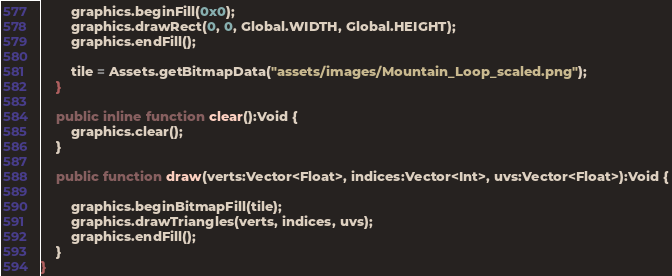<code> <loc_0><loc_0><loc_500><loc_500><_Haxe_>		graphics.beginFill(0x0);
		graphics.drawRect(0, 0, Global.WIDTH, Global.HEIGHT);
		graphics.endFill();
		
		tile = Assets.getBitmapData("assets/images/Mountain_Loop_scaled.png");
	}
	
	public inline function clear():Void {
		graphics.clear();
	}
	
	public function draw(verts:Vector<Float>, indices:Vector<Int>, uvs:Vector<Float>):Void {
		
		graphics.beginBitmapFill(tile);
		graphics.drawTriangles(verts, indices, uvs);
		graphics.endFill();
	}
}</code> 